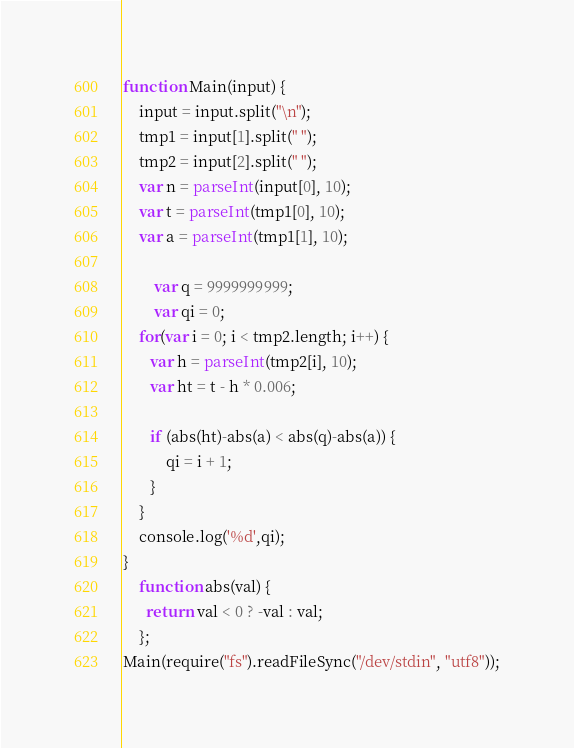<code> <loc_0><loc_0><loc_500><loc_500><_JavaScript_>function Main(input) {
	input = input.split("\n");
	tmp1 = input[1].split(" ");
	tmp2 = input[2].split(" ");
	var n = parseInt(input[0], 10);
	var t = parseInt(tmp1[0], 10);
	var a = parseInt(tmp1[1], 10);

        var q = 9999999999;
        var qi = 0;
	for(var i = 0; i < tmp2.length; i++) {
	   var h = parseInt(tmp2[i], 10);
	   var ht = t - h * 0.006;
	   
       if (abs(ht)-abs(a) < abs(q)-abs(a)) {
           qi = i + 1;
       }
	}
	console.log('%d',qi);
}
	function abs(val) {
	  return val < 0 ? -val : val;
	};
Main(require("fs").readFileSync("/dev/stdin", "utf8"));</code> 